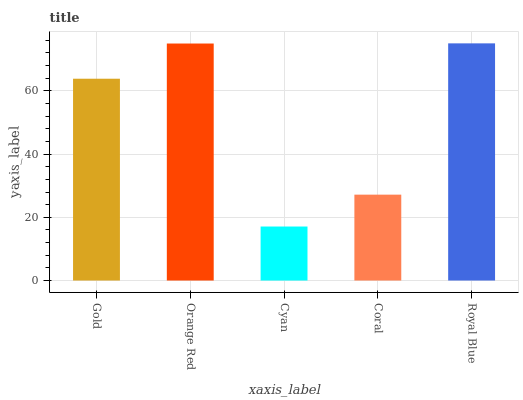Is Cyan the minimum?
Answer yes or no. Yes. Is Royal Blue the maximum?
Answer yes or no. Yes. Is Orange Red the minimum?
Answer yes or no. No. Is Orange Red the maximum?
Answer yes or no. No. Is Orange Red greater than Gold?
Answer yes or no. Yes. Is Gold less than Orange Red?
Answer yes or no. Yes. Is Gold greater than Orange Red?
Answer yes or no. No. Is Orange Red less than Gold?
Answer yes or no. No. Is Gold the high median?
Answer yes or no. Yes. Is Gold the low median?
Answer yes or no. Yes. Is Cyan the high median?
Answer yes or no. No. Is Cyan the low median?
Answer yes or no. No. 